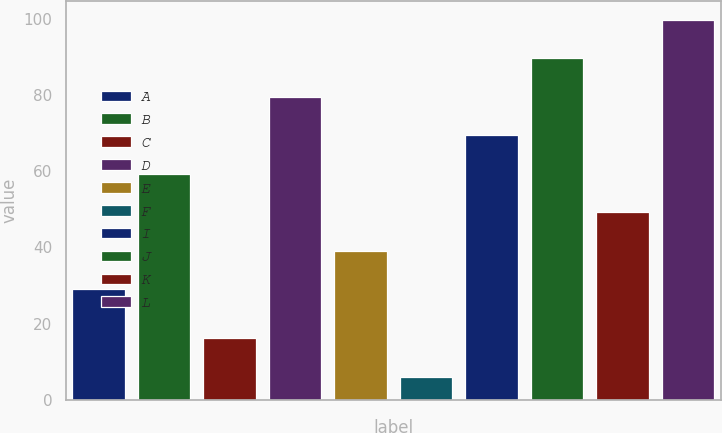Convert chart to OTSL. <chart><loc_0><loc_0><loc_500><loc_500><bar_chart><fcel>A<fcel>B<fcel>C<fcel>D<fcel>E<fcel>F<fcel>I<fcel>J<fcel>K<fcel>L<nl><fcel>29<fcel>59.3<fcel>16.1<fcel>79.5<fcel>39.1<fcel>6<fcel>69.4<fcel>89.6<fcel>49.2<fcel>99.7<nl></chart> 